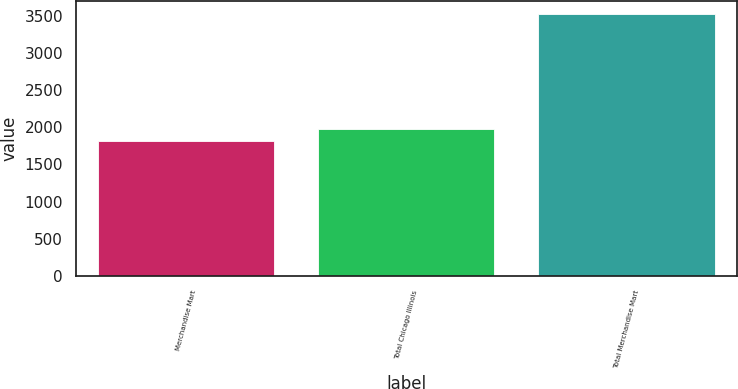<chart> <loc_0><loc_0><loc_500><loc_500><bar_chart><fcel>Merchandise Mart<fcel>Total Chicago Illinois<fcel>Total Merchandise Mart<nl><fcel>1810<fcel>1981.1<fcel>3521<nl></chart> 